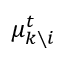<formula> <loc_0><loc_0><loc_500><loc_500>\mu _ { k \ i } ^ { t }</formula> 